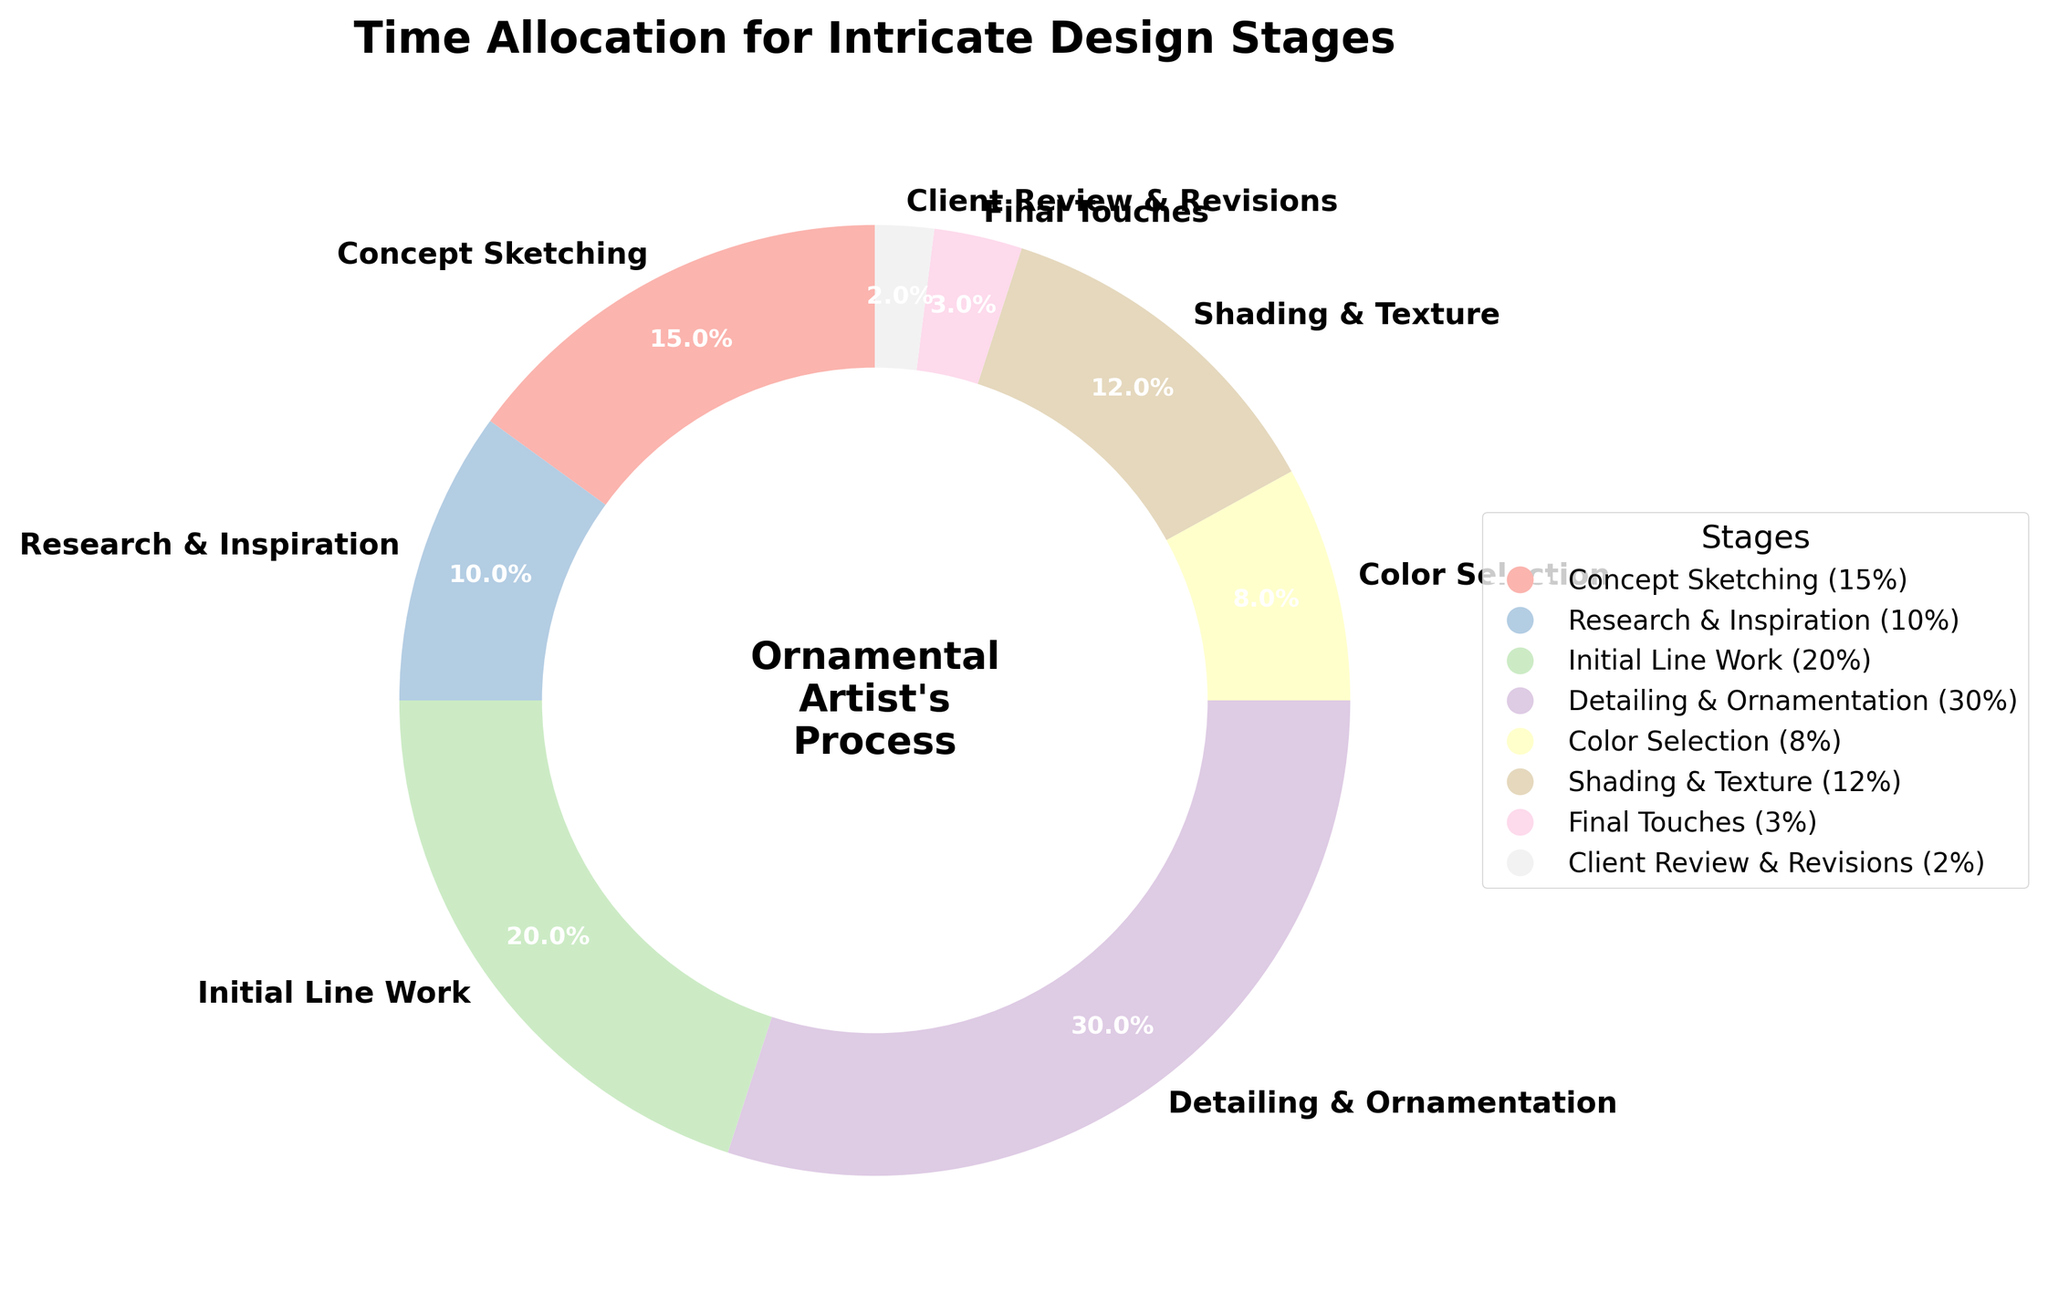What stage takes up the most time in the process? The figure shows different stages with different time allocations. The largest slice of the pie chart corresponds to the "Detailing & Ornamentation" stage.
Answer: Detailing & Ornamentation Which stages have a combined time allocation of 30%? By checking the stages with smaller contributions, "Research & Inspiration" (10%) and "Shading & Texture" (12%), and "Final Touches" (3%), these add up to 25% thus not equivalent to 30%. Adding "Color Selection" (8%) completes the 30%, but rechecking we find that "Concept Sketching" (15%) and "Initial Line Work" (20%) indeed add up to 30%.
Answer: Concept Sketching and Initial Line Work Is the time allocated to "Concept Sketching" greater than "Research & Inspiration" but less than "Initial Line Work"? Comparing the given time allocations: "Concept Sketching" (15%), "Research & Inspiration" (10%), and "Initial Line Work" (20%), indeed, 15% is greater than 10% but less than 20%.
Answer: Yes What is the average time allocation for "Color Selection" and "Shading & Texture"? Adding their percentages, "Color Selection" (8%) and "Shading & Texture" (12%) gives a total of 20%, and the average becomes 20% / 2 = 10%.
Answer: 10% What stage has the least time allocated to it, and what percentage is it? By looking for the smallest slice in the pie chart, we can see that "Client Review & Revisions" is the smallest.
Answer: Client Review & Revisions, 2% What is the combined time allocation for "Shading & Texture" and "Final Touches"? Their respective times are "Shading & Texture" (12%) and "Final Touches" (3%), and summing these gives 12% + 3% = 15%.
Answer: 15% How much more time is allocated to "Detailing & Ornamentation" compared to "Research & Inspiration"? Time for "Detailing & Ornamentation" is 30% and for "Research & Inspiration" is 10%, so the difference is 30% - 10% = 20%.
Answer: 20% Which stages sum to over 50% of the time allocation collectively? Checking the largest contributors "Detailing & Ornamentation" (30%), "Initial Line Work" (20%) already makes 50%, then adding "Concept Sketching" (15%) brings us over 50%.
Answer: Detailing & Ornamentation, Initial Line Work, and Concept Sketching What stage has a color that is visually distinct as the lightest slice in the pie chart? The lightest color in the pie chart corresponds to "Client Review & Revisions" which has a very light pastel shade compared to others.
Answer: Client Review & Revisions 